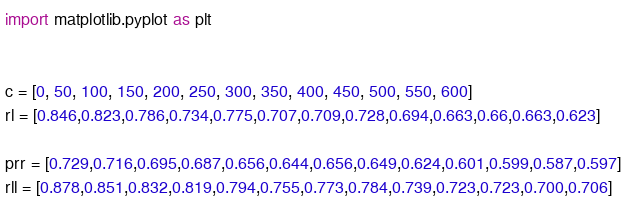<code> <loc_0><loc_0><loc_500><loc_500><_Python_>import matplotlib.pyplot as plt


c = [0, 50, 100, 150, 200, 250, 300, 350, 400, 450, 500, 550, 600]
rl = [0.846,0.823,0.786,0.734,0.775,0.707,0.709,0.728,0.694,0.663,0.66,0.663,0.623]

prr = [0.729,0.716,0.695,0.687,0.656,0.644,0.656,0.649,0.624,0.601,0.599,0.587,0.597]
rll = [0.878,0.851,0.832,0.819,0.794,0.755,0.773,0.784,0.739,0.723,0.723,0.700,0.706]</code> 